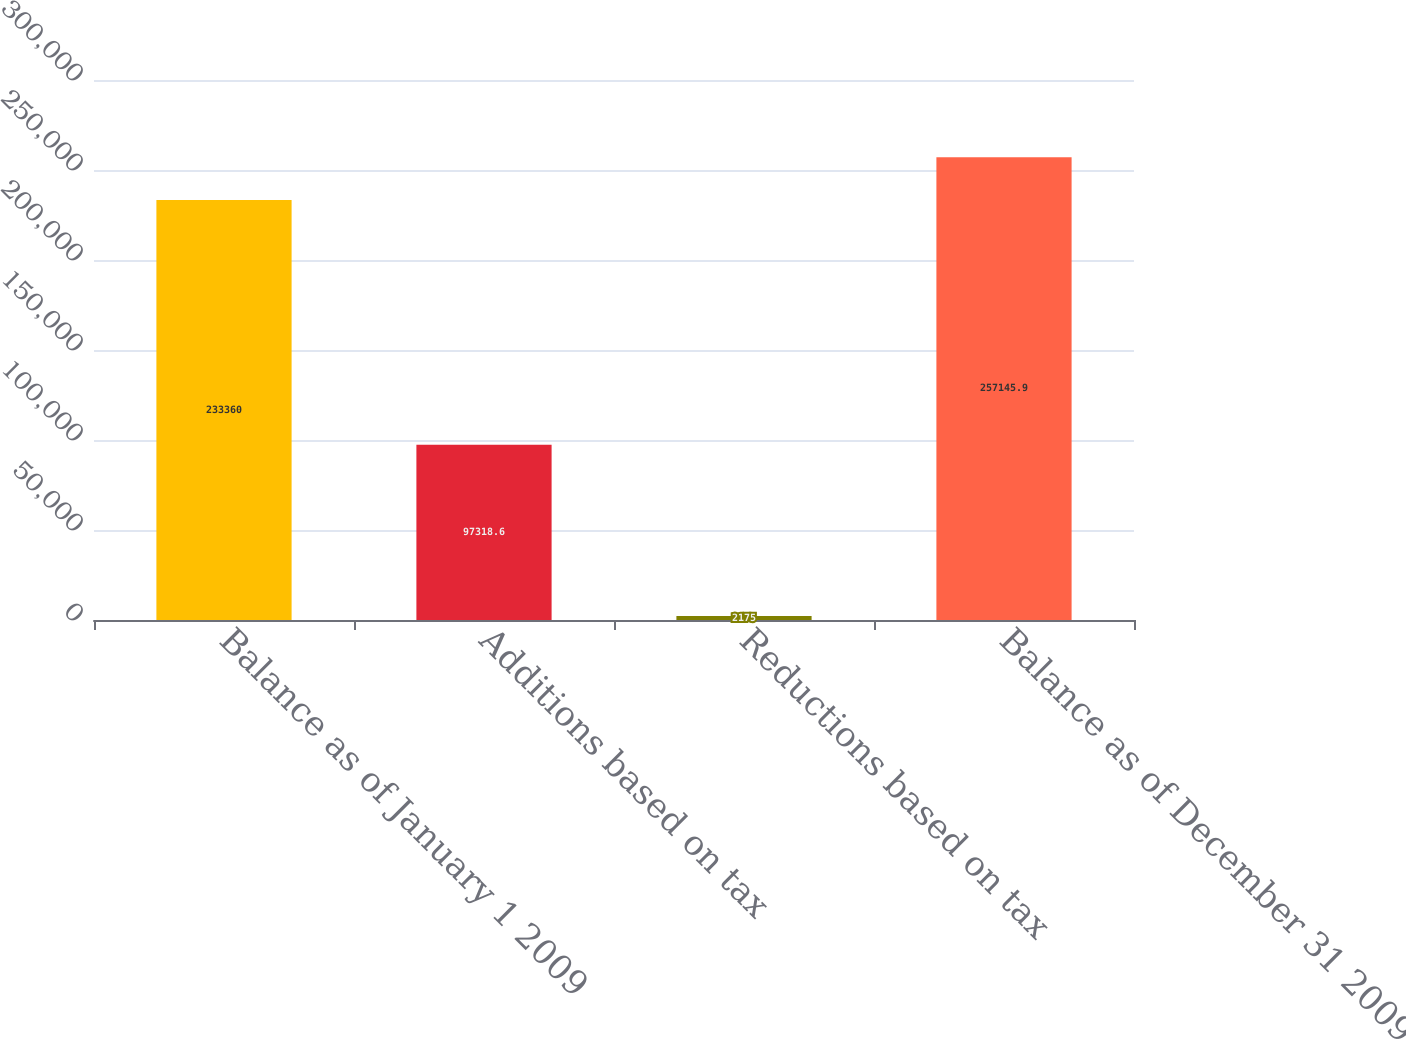Convert chart. <chart><loc_0><loc_0><loc_500><loc_500><bar_chart><fcel>Balance as of January 1 2009<fcel>Additions based on tax<fcel>Reductions based on tax<fcel>Balance as of December 31 2009<nl><fcel>233360<fcel>97318.6<fcel>2175<fcel>257146<nl></chart> 